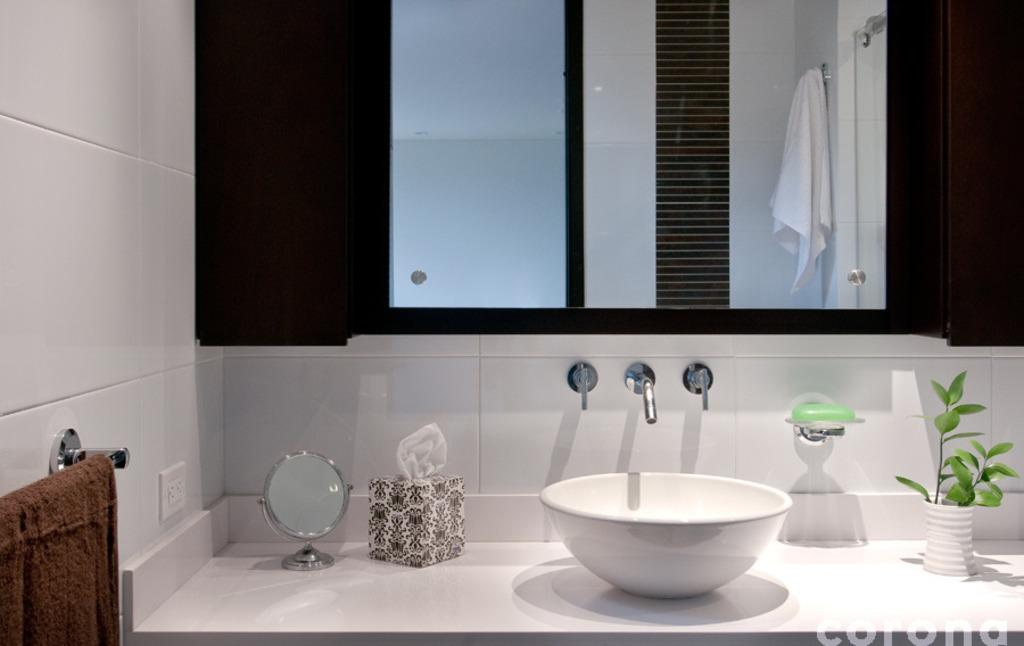What objects in the image are used for personal hygiene? In the image, there is a white-colored sink, a green-colored soap, and a water tap, which are used for personal hygiene. What items in the image are used for cleaning or drying? There are towels and a tissue box in the image, which are used for cleaning or drying. What type of plant is in the image? There is a plant in a white-colored pot in the image. What is the color of the sink in the image? The sink in the image is white-colored. What is the color of the soap in the image? The soap in the image is green-colored. Can you hear the sound of thunder in the image? There is no sound in the image, and therefore, no thunder can be heard. 